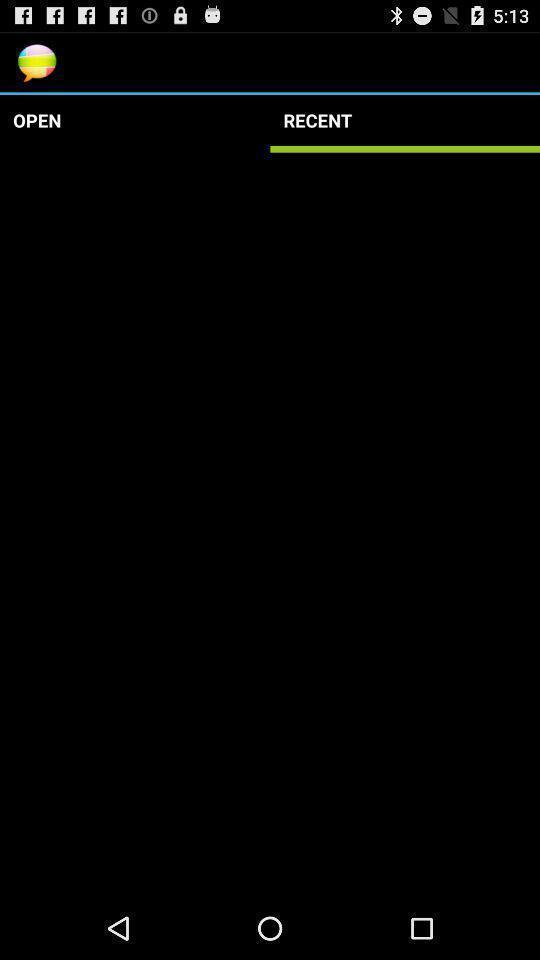Provide a detailed account of this screenshot. Screen shows a blank page on recent chat. 